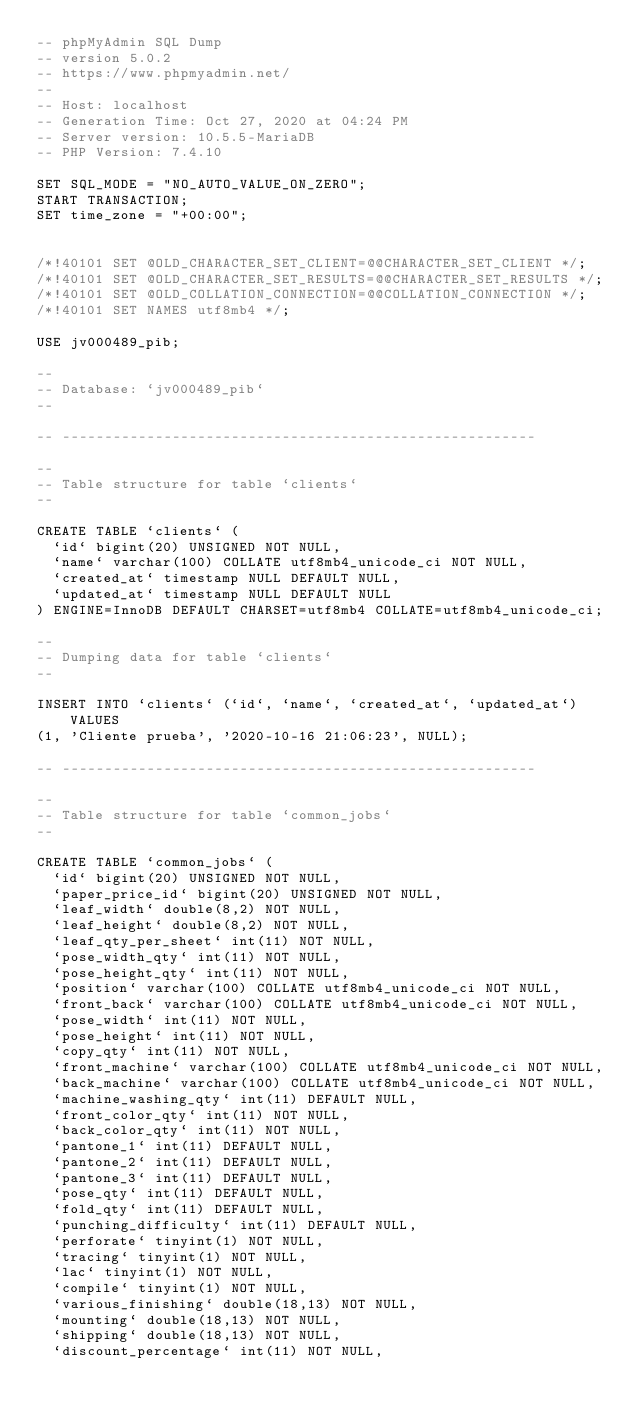<code> <loc_0><loc_0><loc_500><loc_500><_SQL_>-- phpMyAdmin SQL Dump
-- version 5.0.2
-- https://www.phpmyadmin.net/
--
-- Host: localhost
-- Generation Time: Oct 27, 2020 at 04:24 PM
-- Server version: 10.5.5-MariaDB
-- PHP Version: 7.4.10

SET SQL_MODE = "NO_AUTO_VALUE_ON_ZERO";
START TRANSACTION;
SET time_zone = "+00:00";


/*!40101 SET @OLD_CHARACTER_SET_CLIENT=@@CHARACTER_SET_CLIENT */;
/*!40101 SET @OLD_CHARACTER_SET_RESULTS=@@CHARACTER_SET_RESULTS */;
/*!40101 SET @OLD_COLLATION_CONNECTION=@@COLLATION_CONNECTION */;
/*!40101 SET NAMES utf8mb4 */;

USE jv000489_pib;	

--
-- Database: `jv000489_pib`
--

-- --------------------------------------------------------

--
-- Table structure for table `clients`
--

CREATE TABLE `clients` (
  `id` bigint(20) UNSIGNED NOT NULL,
  `name` varchar(100) COLLATE utf8mb4_unicode_ci NOT NULL,
  `created_at` timestamp NULL DEFAULT NULL,
  `updated_at` timestamp NULL DEFAULT NULL
) ENGINE=InnoDB DEFAULT CHARSET=utf8mb4 COLLATE=utf8mb4_unicode_ci;

--
-- Dumping data for table `clients`
--

INSERT INTO `clients` (`id`, `name`, `created_at`, `updated_at`) VALUES
(1, 'Cliente prueba', '2020-10-16 21:06:23', NULL);

-- --------------------------------------------------------

--
-- Table structure for table `common_jobs`
--

CREATE TABLE `common_jobs` (
  `id` bigint(20) UNSIGNED NOT NULL,
  `paper_price_id` bigint(20) UNSIGNED NOT NULL,
  `leaf_width` double(8,2) NOT NULL,
  `leaf_height` double(8,2) NOT NULL,
  `leaf_qty_per_sheet` int(11) NOT NULL,
  `pose_width_qty` int(11) NOT NULL,
  `pose_height_qty` int(11) NOT NULL,
  `position` varchar(100) COLLATE utf8mb4_unicode_ci NOT NULL,
  `front_back` varchar(100) COLLATE utf8mb4_unicode_ci NOT NULL,
  `pose_width` int(11) NOT NULL,
  `pose_height` int(11) NOT NULL,
  `copy_qty` int(11) NOT NULL,
  `front_machine` varchar(100) COLLATE utf8mb4_unicode_ci NOT NULL,
  `back_machine` varchar(100) COLLATE utf8mb4_unicode_ci NOT NULL,
  `machine_washing_qty` int(11) DEFAULT NULL,
  `front_color_qty` int(11) NOT NULL,
  `back_color_qty` int(11) NOT NULL,
  `pantone_1` int(11) DEFAULT NULL,
  `pantone_2` int(11) DEFAULT NULL,
  `pantone_3` int(11) DEFAULT NULL,
  `pose_qty` int(11) DEFAULT NULL,
  `fold_qty` int(11) DEFAULT NULL,
  `punching_difficulty` int(11) DEFAULT NULL,
  `perforate` tinyint(1) NOT NULL,
  `tracing` tinyint(1) NOT NULL,
  `lac` tinyint(1) NOT NULL,
  `compile` tinyint(1) NOT NULL,
  `various_finishing` double(18,13) NOT NULL,
  `mounting` double(18,13) NOT NULL,
  `shipping` double(18,13) NOT NULL,
  `discount_percentage` int(11) NOT NULL,</code> 